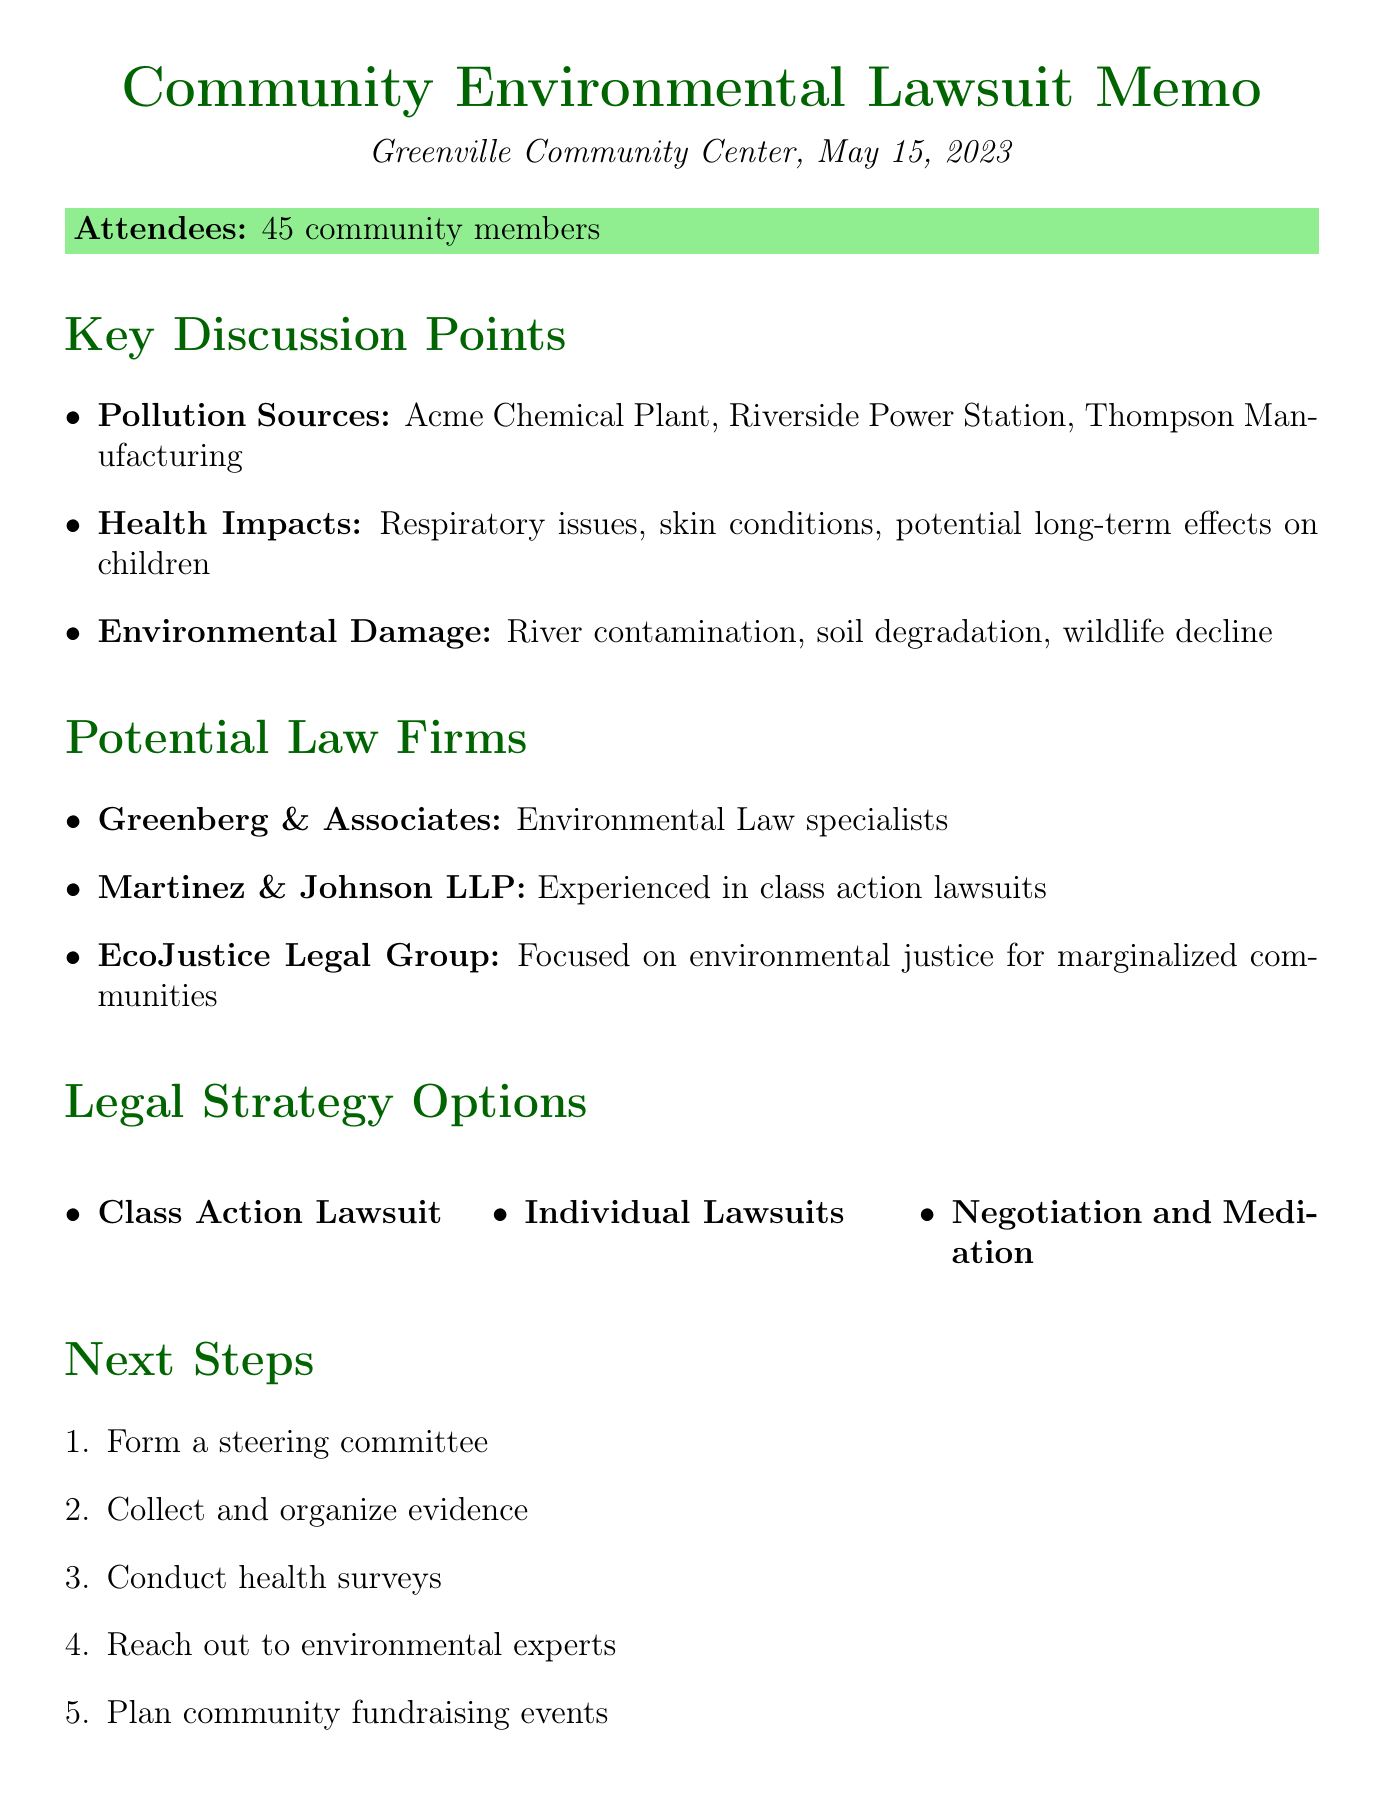What date was the community gathering held? The document states that the community gathering took place on May 15, 2023.
Answer: May 15, 2023 How many community members attended the meeting? The memo indicates that there were 45 attendees at the meeting.
Answer: 45 What is one of the identified major pollution sources? The document mentions Acme Chemical Plant as a major polluter.
Answer: Acme Chemical Plant Which legal strategy option allows for shared legal costs? Class Action Lawsuit offers strength in numbers and shared legal costs.
Answer: Class Action Lawsuit What is the specialization of Martinez & Johnson LLP? According to the document, Martinez & Johnson LLP specializes in class action lawsuits.
Answer: Class Action Lawsuits What health issue was discussed at the gathering? The key discussion points included increased cases of respiratory issues.
Answer: Respiratory issues Who is responsible for providing scientific data and expert contacts? The Greenville Environmental Action Group is responsible for this.
Answer: Greenville Environmental Action Group What is one of the next steps listed in the memo? The memo lists forming a steering committee as one of the next steps.
Answer: Form a steering committee What type of legal firm is EcoJustice Legal Group? The document describes EcoJustice Legal Group as focused on environmental justice.
Answer: Environmental Justice 